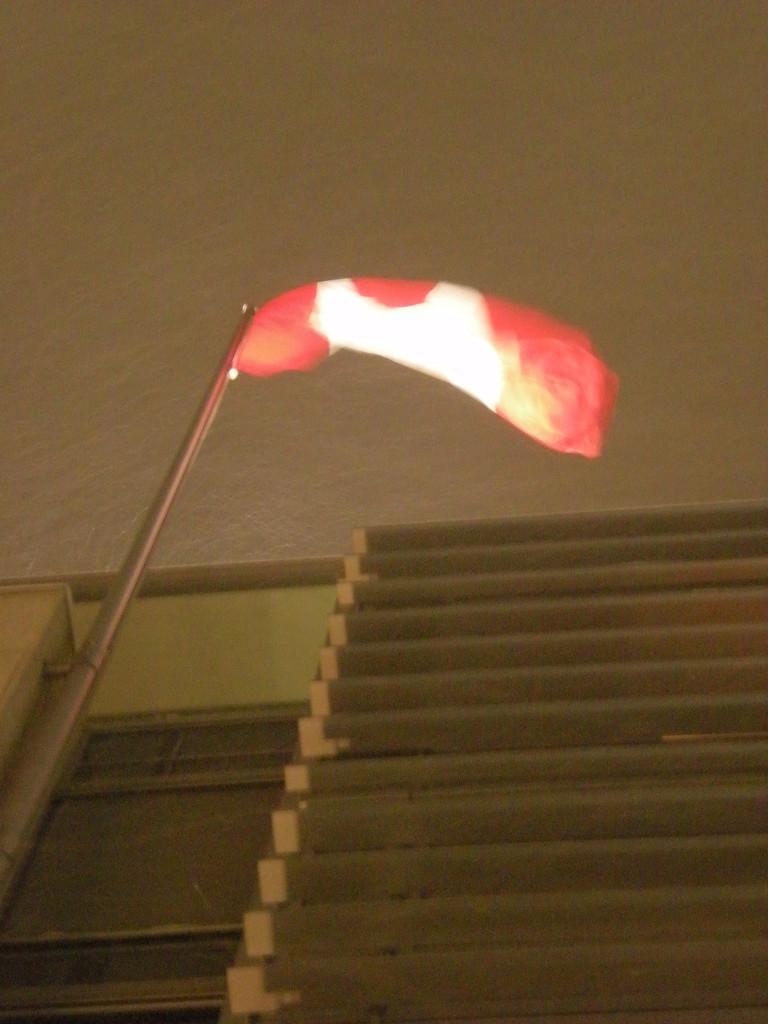Could you give a brief overview of what you see in this image? In this image I can see a metal rod and I can see a red colour thing over here. 